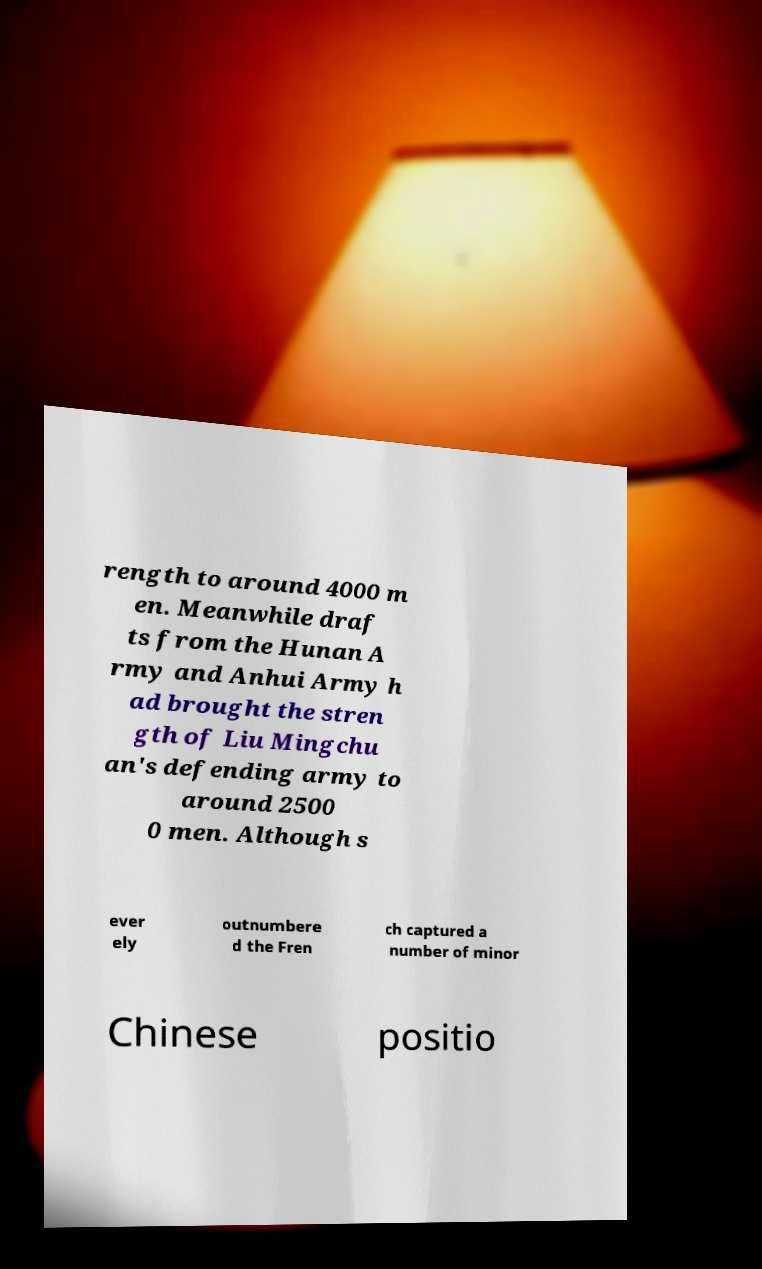I need the written content from this picture converted into text. Can you do that? rength to around 4000 m en. Meanwhile draf ts from the Hunan A rmy and Anhui Army h ad brought the stren gth of Liu Mingchu an's defending army to around 2500 0 men. Although s ever ely outnumbere d the Fren ch captured a number of minor Chinese positio 